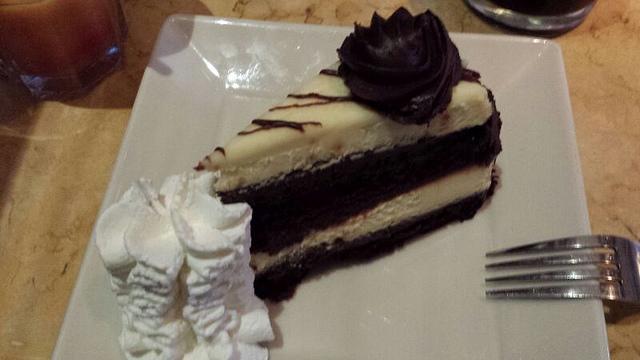Did someone bake this cake?
Short answer required. Yes. Is everything on the plate edible?
Quick response, please. Yes. Is this a freshly made tortilla?
Write a very short answer. No. Is the fork facing up or down?
Give a very brief answer. Down. What kind of dessert is this?
Give a very brief answer. Cake. 